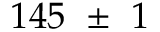Convert formula to latex. <formula><loc_0><loc_0><loc_500><loc_500>1 4 5 \pm 1</formula> 